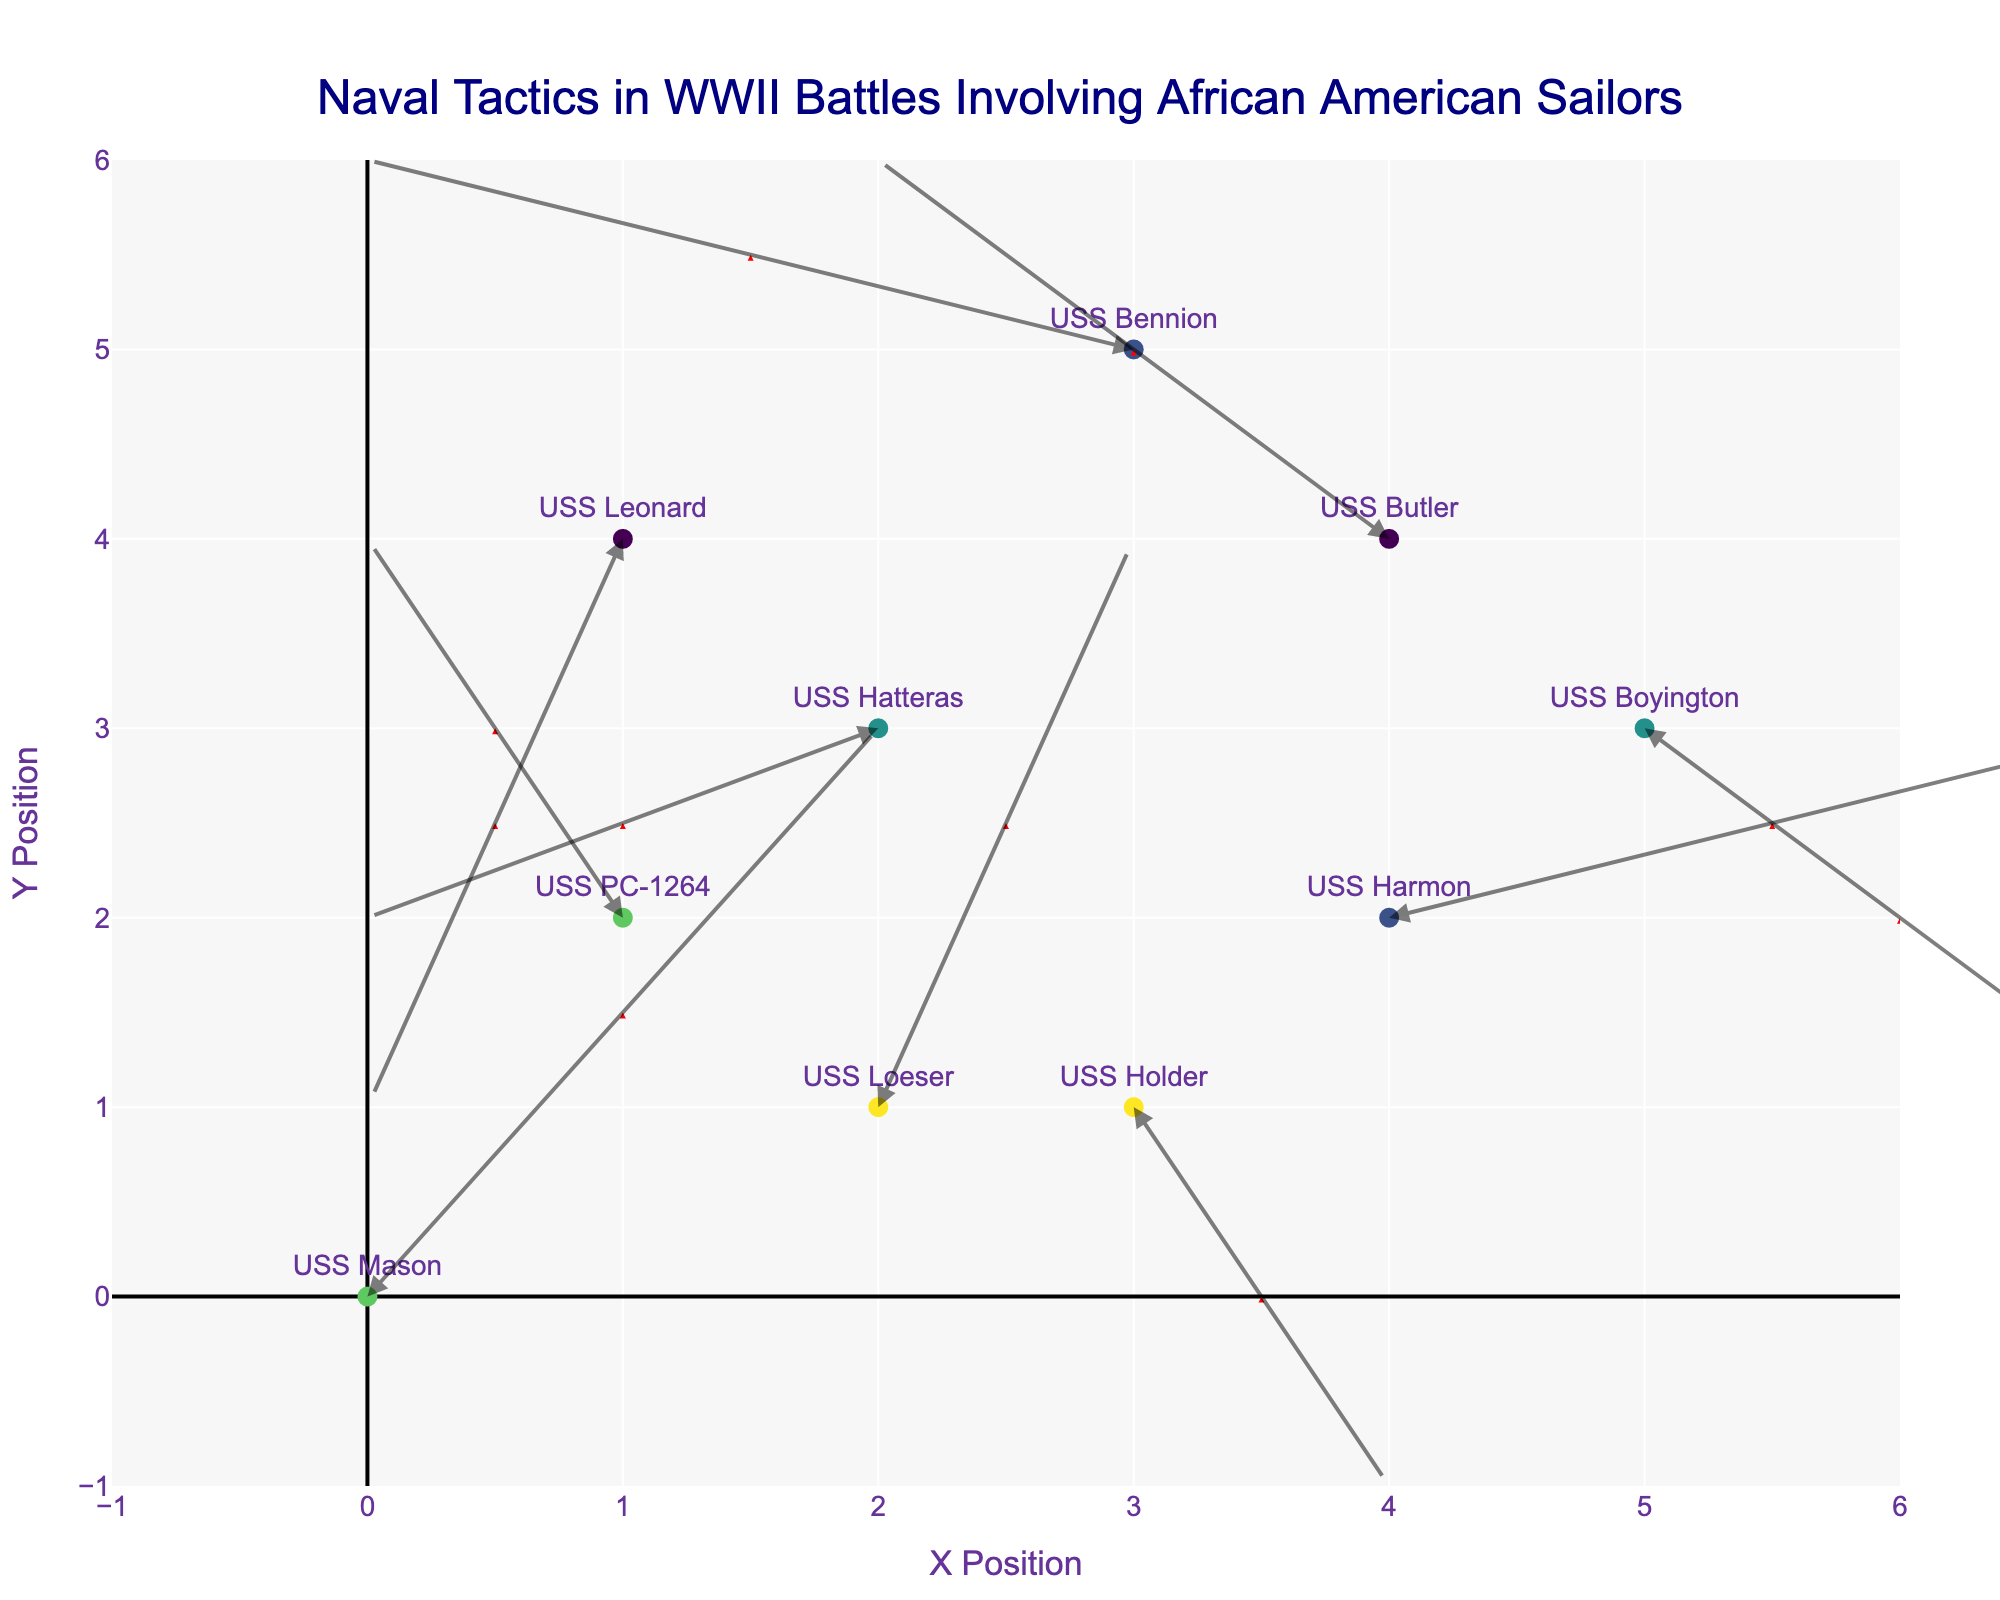What's the title of the figure? The title is displayed at the top center of the figure. It states, "Naval Tactics in WWII Battles Involving African American Sailors".
Answer: "Naval Tactics in WWII Battles Involving African American Sailors" How many different battles are represented in the figure? We can determine the number of battles by counting the unique values in the 'battle' categories from the hover text of the markers.
Answer: 5 Which ship had the largest magnitude of movement in the Battle of Okinawa? To determine this, we need to calculate the magnitude (sqrt(u^2 + v^2)) for ships involved in the Battle of Okinawa. USS Hatteras has movements u = -2, v = -1 resulting in a magnitude sqrt(4+1)=sqrt(5)≈2.24. USS Boyington has u = 2, v = -2 with a magnitude sqrt(4+4)=sqrt(8)≈2.83, which is larger than USS Hatteras.
Answer: USS Boyington What is the direction of movement for the USS Leonard in the Battle of Iwo Jima? By looking at the quiver arrow direction for USS Leonard, located at (1, 4), the arrow moves towards (-1, -3). This denotes a south-west direction.
Answer: South-West Which battle involved the highest number of ships? By counting the ship names that correspond to each battle from the hover text, we can determine the Battle of Leyte Gulf has 2 ships: USS Harmon and USS Bennion. Other battles have 1 ship each.
Answer: Battle of Leyte Gulf What is the average x-coordinate position of ships involved in the Operation Neptune battle? For Operation Neptune, identify the ships: USS Holder (x=3) and USS Loeser (x=2). The average x is (3 + 2) / 2 = 2.5.
Answer: 2.5 Compare the movements of USS Harmon and USS Bennion in the Battle of Leyte Gulf. Which ship had a greater change in y-coordinate? The change in y-coordinate (v) for USS Harmon is +1 and for USS Bennion is +1. Since these are equal, there is no ship with a greater change.
Answer: Equal Which ship had the highest total distance traveled (combining both x and y movements)? We calculate the Euclidean distance for each ship using sqrt(u^2 + v^2). USS Boyington's distance is sqrt(2^2+(-2)^2) = sqrt(8) ≈ 2.83, which is the largest compared to other ships.
Answer: USS Boyington What's the median y-coordinate of all starting positions of the ships? Collect all y coordinates: 0, 2, 1, 3, 2, 4, 3, 5, 1, 4. Sorted: 0, 1, 1, 2, 2, 3, 3, 4, 4, 5. Median y-coordinate is the average of the 5th and 6th values (2+3)/2 = 2.5.
Answer: 2.5 